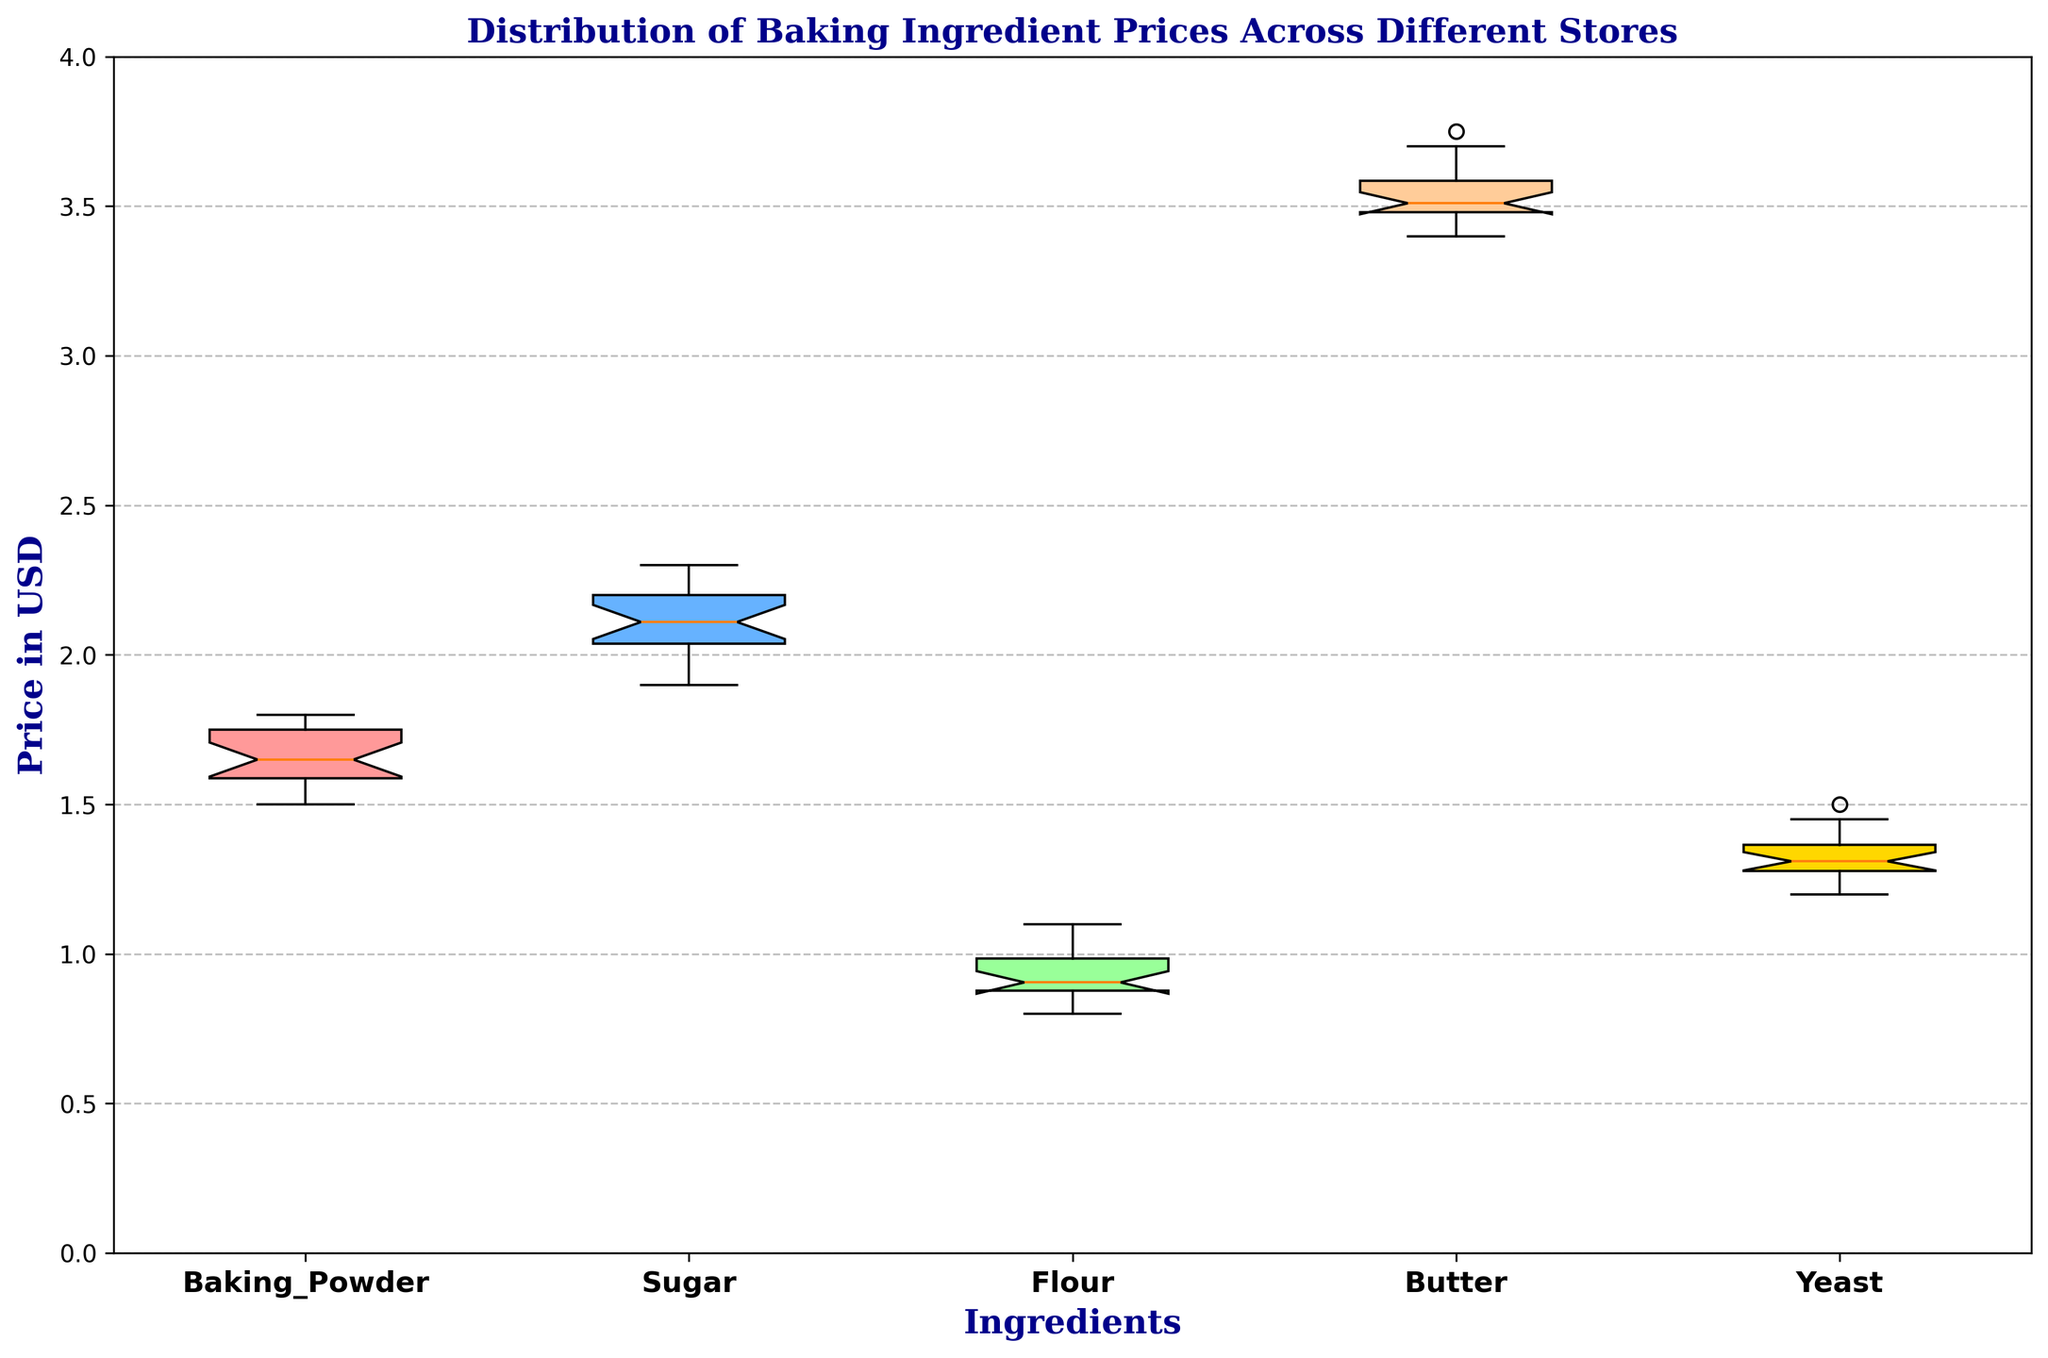Which ingredient has the highest median price? To answer this, we look for the ingredient with the highest middle value (median) in the box plot. From the box plot, observe the line inside each box (median line) and identify which is the highest.
Answer: Butter Which ingredient has the most variation in price? Variation can be evaluated by looking at the length of the boxes and the whiskers in the box plot. The ingredient with the tallest box and longest whiskers has the most variation.
Answer: Butter How does the price range of Baking Powder compare to that of Sugar? We compare the range between the minimum and maximum prices (whiskers) for both Baking Powder and Sugar. By observing the plot, Baking Powder has a relatively smaller range compared to Sugar.
Answer: Baking Powder has a smaller price range than Sugar What is the median price of Flour, and how does it compare to Yeast? Identify the median line in the box plots of both Flour and Yeast. From the plot, observe and compare the position of these lines on the y-axis.
Answer: Flour's median price is lower than Yeast's median price Which ingredient has the least median price? To find this, we look at the median line inside the boxes and identify the lowest one across all the ingredients.
Answer: Flour Are the prices of Butter generally higher than those of Baking Powder? We compare the overall level of the box and whiskers of Butter to those of Baking Powder to see if the values are generally higher. From the plot, it's clear that Butter's prices are generally higher.
Answer: Yes Which ingredient's prices are more closely clustered together? This is determined by looking for the box plot with the shortest box and whiskers, indicating less variability in prices.
Answer: Baking Powder What is the interquartile range (IQR) of Sugar's price? The IQR is the difference between the upper quartile (top of the box) and the lower quartile (bottom of the box). From the plot, we can visually estimate this range for Sugar.
Answer: ~0.25 How does the upper quartile of Butter's price compare to the upper quartile of Yeast's price? For this, we compare the top boundary of the boxes (upper quartile) for both Butter and Yeast on the y-axis. The higher top boundary indicates a higher upper quartile.
Answer: Butter's upper quartile is higher than Yeast's What's the median price of Baking Powder, and is it higher or lower compared to Flour? Find the median line in the box plot for both Baking Powder and Flour and compare their positions on the y-axis to determine which is higher.
Answer: Baking Powder's median price is higher than Flour's 